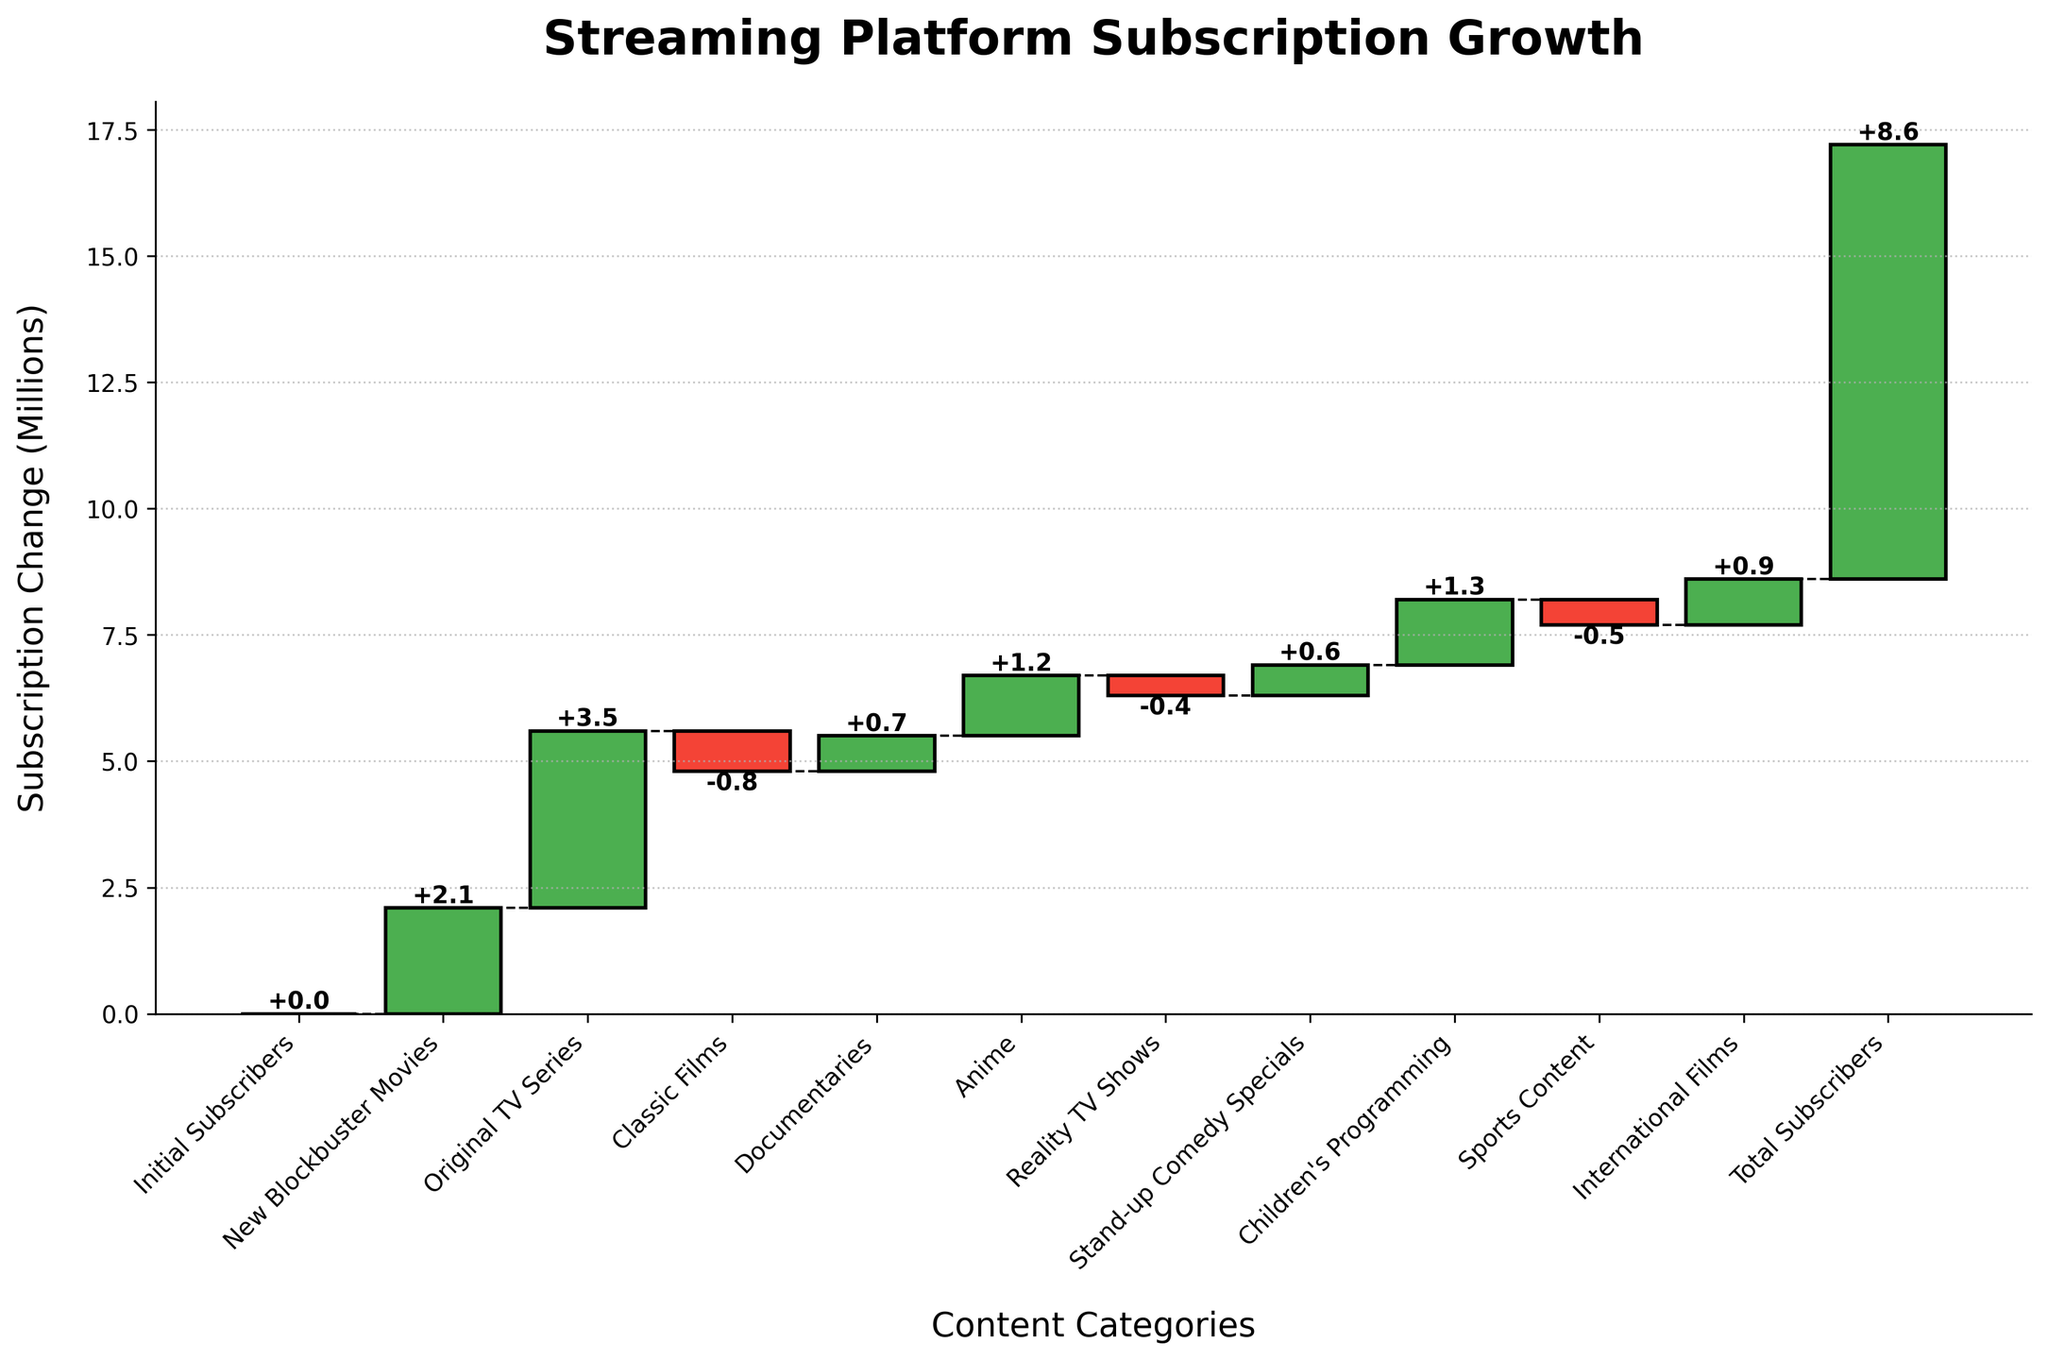What's the title of the chart? Simply read the title text at the top of the figure.
Answer: Streaming Platform Subscription Growth How many categories showed a decline in subscribers? Identify categories where the bars are red (negative changes) and count them. The categories with red bars are "Classic Films" (-0.8), "Reality TV Shows" (-0.4), and "Sports Content" (-0.5), making a total of three.
Answer: 3 Which category contributed the most to subscription growth? Identify the category with the highest positive change. The highest positive change is from "Original TV Series" which is +3.5 million.
Answer: Original TV Series How many categories contributed positively to the subscription growth? Count the categories with green bars (positive changes). The categories with green bars are "New Blockbuster Movies", "Original TV Series", "Documentaries", "Anime", "Stand-up Comedy Specials", "Children's Programming", and "International Films", which totals seven.
Answer: 7 What is the cumulative change at the "Anime" category? Sum up changes from the initial to the "Anime" category: Initial (0) + New Blockbuster Movies (+2.1) + Original TV Series (+3.5) + Classic Films (-0.8) + Documentaries (+0.7) gives a cumulative change of +5.5 at "Anime". Adding Anime (+1.2) gives +6.7 million.
Answer: +6.7 What is the net change in subscribers for the "Reality TV Shows" category? Read the value next to the "Reality TV Shows" bar. The bar indicates a change of -0.4 million.
Answer: -0.4 Which category follows "Children's Programming" in terms of positive impact on subscribers? First, identify the "Children's Programming" bar, which has a positive change of +1.3 million. The next category with positive impact after this is "International Films" with +0.9.
Answer: International Films What is the combined impact on subscribers from "Classic Films" and "Sports Content"? Add the changes from "Classic Films" (-0.8) and "Sports Content" (-0.5). The combined impact is -0.8 + (-0.5) = -1.3 million.
Answer: -1.3 What is the total change in subscribers? The total change in subscribers is represented by the last number on the chart, labeled "Total Subscribers", which is +8.6 million.
Answer: +8.6 